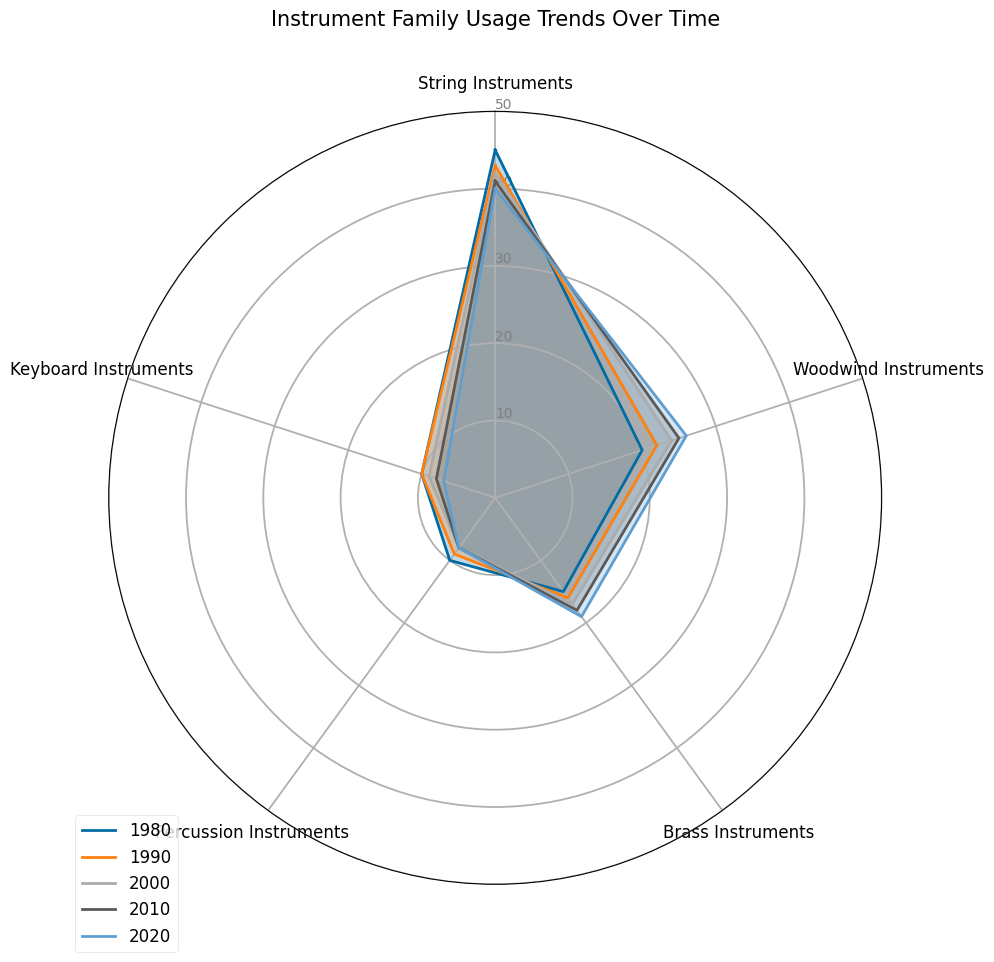Which instrument family showed the most steady decrease in usage from 1980 to 2020? To find the instrument family with the most steady decrease, observe each line's slope from 1980 to 2020. The "String Instruments" line consistently declines from 45 units in 1980 to 40 units in 2020.
Answer: String Instruments Between which periods did the usage of Brass Instruments increase the most? Calculate the increase for each decade. From 1980 to 1990 (+1), 1990 to 2000 (+1), 2000 to 2010 (+1), 2010 to 2020 (+1). Brass Instruments increased the most between 1980 and 2020.
Answer: 1980 to 1990, and equal for each subsequent decade Which instrument family had the highest usage in 1980? Observe the radar chart for the line representing 1980, and “String Instruments” has the highest value at 45 units.
Answer: String Instruments What is the combined usage of Woodwind and Brass Instruments in 2000? First, find the usage of Woodwind Instruments (24 units) and Brass Instruments (17 units) in 2000. Adding these values gives 24 + 17 = 41 units.
Answer: 41 What was the percent change in Keyboard Instruments’ usage from 1980 to 2020? Calculate the difference in usage from 1980 (10 units) and 2020 (7 units). The percent change is ((10-7)/10)*100 = 30%.
Answer: 30% Which instrument family overtook another's usage between 1980 and 2020? Compare line intersections between 1980 and 2020. Woodwind Instruments (20 units in 1980 to 26 units in 2020) overtook String Instruments usage which decreased.
Answer: Woodwind Instruments overtook String Instruments What is the average usage of Percussion Instruments across all years? Sum up the Percussion Instruments’ usage from each decade (10 + 9 + 8 + 8 + 8) = 43 and divide by the number of decades (5). The average is 43 / 5 = 8.6.
Answer: 8.6 How did the number of families with decreased usage from 1980 to 2020 compare to families with increased usage? Count the families with decreased usage (String Instruments, Keyboard Instruments) and those with increased usage (Woodwind Instruments, Brass Instruments, Percussion Instruments). Two decreased, three increased.
Answer: 2 decreased, 3 increased Which decade shows the least change for any instrument family? Judging by visual length of line segments, Percussion Instruments held steady from 2000 to 2020, barely changing visually.
Answer: 2010 to 2020 for Percussion Instruments 